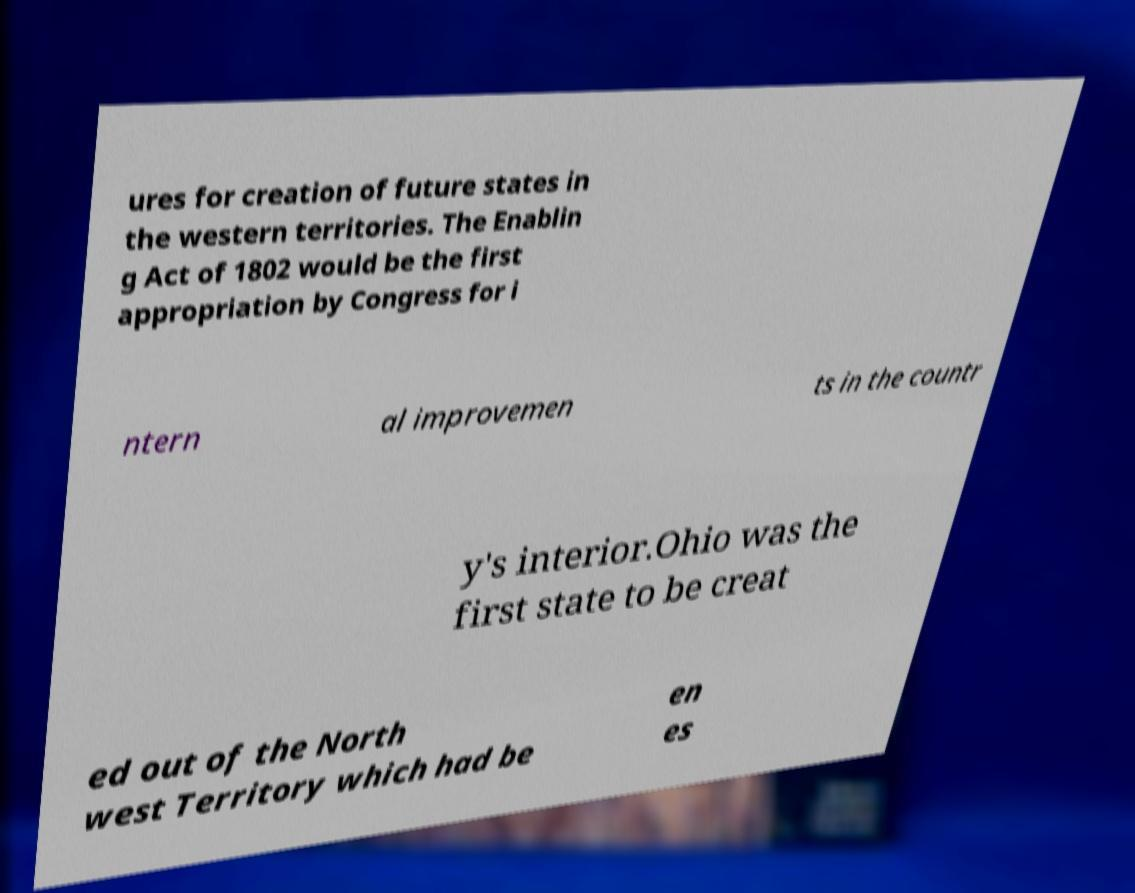Can you accurately transcribe the text from the provided image for me? ures for creation of future states in the western territories. The Enablin g Act of 1802 would be the first appropriation by Congress for i ntern al improvemen ts in the countr y's interior.Ohio was the first state to be creat ed out of the North west Territory which had be en es 